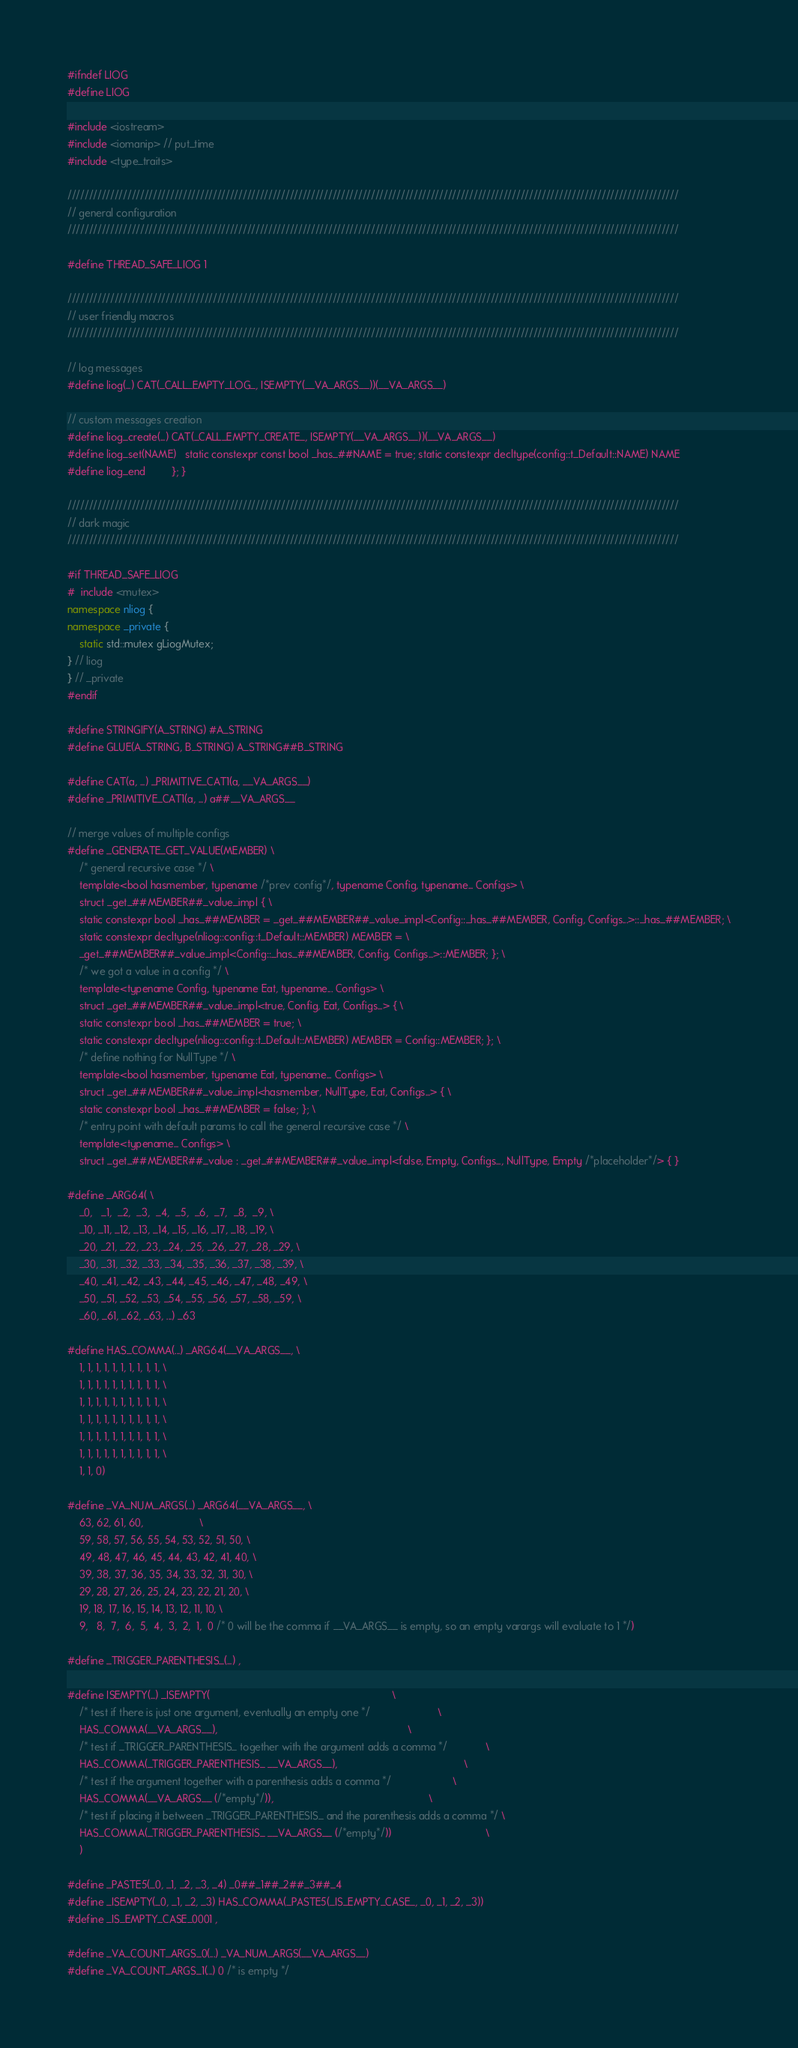<code> <loc_0><loc_0><loc_500><loc_500><_C++_>#ifndef LIOG
#define LIOG

#include <iostream>
#include <iomanip> // put_time
#include <type_traits>

///////////////////////////////////////////////////////////////////////////////////////////////////////////////////////////////////////////////
// general configuration
///////////////////////////////////////////////////////////////////////////////////////////////////////////////////////////////////////////////

#define THREAD_SAFE_LIOG 1

///////////////////////////////////////////////////////////////////////////////////////////////////////////////////////////////////////////////
// user friendly macros
///////////////////////////////////////////////////////////////////////////////////////////////////////////////////////////////////////////////

// log messages
#define liog(...) CAT(_CALL_EMPTY_LOG_, ISEMPTY(__VA_ARGS__))(__VA_ARGS__)

// custom messages creation
#define liog_create(...) CAT(_CALL_EMPTY_CREATE_, ISEMPTY(__VA_ARGS__))(__VA_ARGS__)
#define liog_set(NAME)   static constexpr const bool _has_##NAME = true; static constexpr decltype(config::t_Default::NAME) NAME
#define liog_end         }; }

///////////////////////////////////////////////////////////////////////////////////////////////////////////////////////////////////////////////
// dark magic
///////////////////////////////////////////////////////////////////////////////////////////////////////////////////////////////////////////////

#if THREAD_SAFE_LIOG
#  include <mutex>
namespace nliog {
namespace _private {
    static std::mutex gLiogMutex;
} // liog
} // _private
#endif

#define STRINGIFY(A_STRING) #A_STRING
#define GLUE(A_STRING, B_STRING) A_STRING##B_STRING

#define CAT(a, ...) _PRIMITIVE_CAT1(a, __VA_ARGS__)
#define _PRIMITIVE_CAT1(a, ...) a##__VA_ARGS__

// merge values of multiple configs
#define _GENERATE_GET_VALUE(MEMBER) \
    /* general recursive case */ \
    template<bool hasmember, typename /*prev config*/, typename Config, typename... Configs> \
    struct _get_##MEMBER##_value_impl { \
    static constexpr bool _has_##MEMBER = _get_##MEMBER##_value_impl<Config::_has_##MEMBER, Config, Configs...>::_has_##MEMBER; \
    static constexpr decltype(nliog::config::t_Default::MEMBER) MEMBER = \
    _get_##MEMBER##_value_impl<Config::_has_##MEMBER, Config, Configs...>::MEMBER; }; \
    /* we got a value in a config */ \
    template<typename Config, typename Eat, typename... Configs> \
    struct _get_##MEMBER##_value_impl<true, Config, Eat, Configs...> { \
    static constexpr bool _has_##MEMBER = true; \
    static constexpr decltype(nliog::config::t_Default::MEMBER) MEMBER = Config::MEMBER; }; \
    /* define nothing for NullType */ \
    template<bool hasmember, typename Eat, typename... Configs> \
    struct _get_##MEMBER##_value_impl<hasmember, NullType, Eat, Configs...> { \
    static constexpr bool _has_##MEMBER = false; }; \
    /* entry point with default params to call the general recursive case */ \
    template<typename... Configs> \
    struct _get_##MEMBER##_value : _get_##MEMBER##_value_impl<false, Empty, Configs..., NullType, Empty /*placeholder*/> { }

#define _ARG64( \
    _0,   _1,  _2,  _3,  _4,  _5,  _6,  _7,  _8,  _9, \
    _10, _11, _12, _13, _14, _15, _16, _17, _18, _19, \
    _20, _21, _22, _23, _24, _25, _26, _27, _28, _29, \
    _30, _31, _32, _33, _34, _35, _36, _37, _38, _39, \
    _40, _41, _42, _43, _44, _45, _46, _47, _48, _49, \
    _50, _51, _52, _53, _54, _55, _56, _57, _58, _59, \
    _60, _61, _62, _63, ...) _63

#define HAS_COMMA(...) _ARG64(__VA_ARGS__, \
    1, 1, 1, 1, 1, 1, 1, 1, 1, 1, \
    1, 1, 1, 1, 1, 1, 1, 1, 1, 1, \
    1, 1, 1, 1, 1, 1, 1, 1, 1, 1, \
    1, 1, 1, 1, 1, 1, 1, 1, 1, 1, \
    1, 1, 1, 1, 1, 1, 1, 1, 1, 1, \
    1, 1, 1, 1, 1, 1, 1, 1, 1, 1, \
    1, 1, 0)

#define _VA_NUM_ARGS(...) _ARG64(__VA_ARGS__, \
    63, 62, 61, 60,                   \
    59, 58, 57, 56, 55, 54, 53, 52, 51, 50, \
    49, 48, 47, 46, 45, 44, 43, 42, 41, 40, \
    39, 38, 37, 36, 35, 34, 33, 32, 31, 30, \
    29, 28, 27, 26, 25, 24, 23, 22, 21, 20, \
    19, 18, 17, 16, 15, 14, 13, 12, 11, 10, \
    9,   8,  7,  6,  5,  4,  3,  2,  1,  0 /* 0 will be the comma if __VA_ARGS__ is empty, so an empty varargs will evaluate to 1 */)

#define _TRIGGER_PARENTHESIS_(...) ,

#define ISEMPTY(...) _ISEMPTY(                                                              \
    /* test if there is just one argument, eventually an empty one */                       \
    HAS_COMMA(__VA_ARGS__),                                                                 \
    /* test if _TRIGGER_PARENTHESIS_ together with the argument adds a comma */             \
    HAS_COMMA(_TRIGGER_PARENTHESIS_ __VA_ARGS__),                                           \
    /* test if the argument together with a parenthesis adds a comma */                     \
    HAS_COMMA(__VA_ARGS__ (/*empty*/)),                                                     \
    /* test if placing it between _TRIGGER_PARENTHESIS_ and the parenthesis adds a comma */ \
    HAS_COMMA(_TRIGGER_PARENTHESIS_ __VA_ARGS__ (/*empty*/))                                \
    )

#define _PASTE5(_0, _1, _2, _3, _4) _0##_1##_2##_3##_4
#define _ISEMPTY(_0, _1, _2, _3) HAS_COMMA(_PASTE5(_IS_EMPTY_CASE_, _0, _1, _2, _3))
#define _IS_EMPTY_CASE_0001 ,

#define _VA_COUNT_ARGS_0(...) _VA_NUM_ARGS(__VA_ARGS__)
#define _VA_COUNT_ARGS_1(...) 0 /* is empty */</code> 